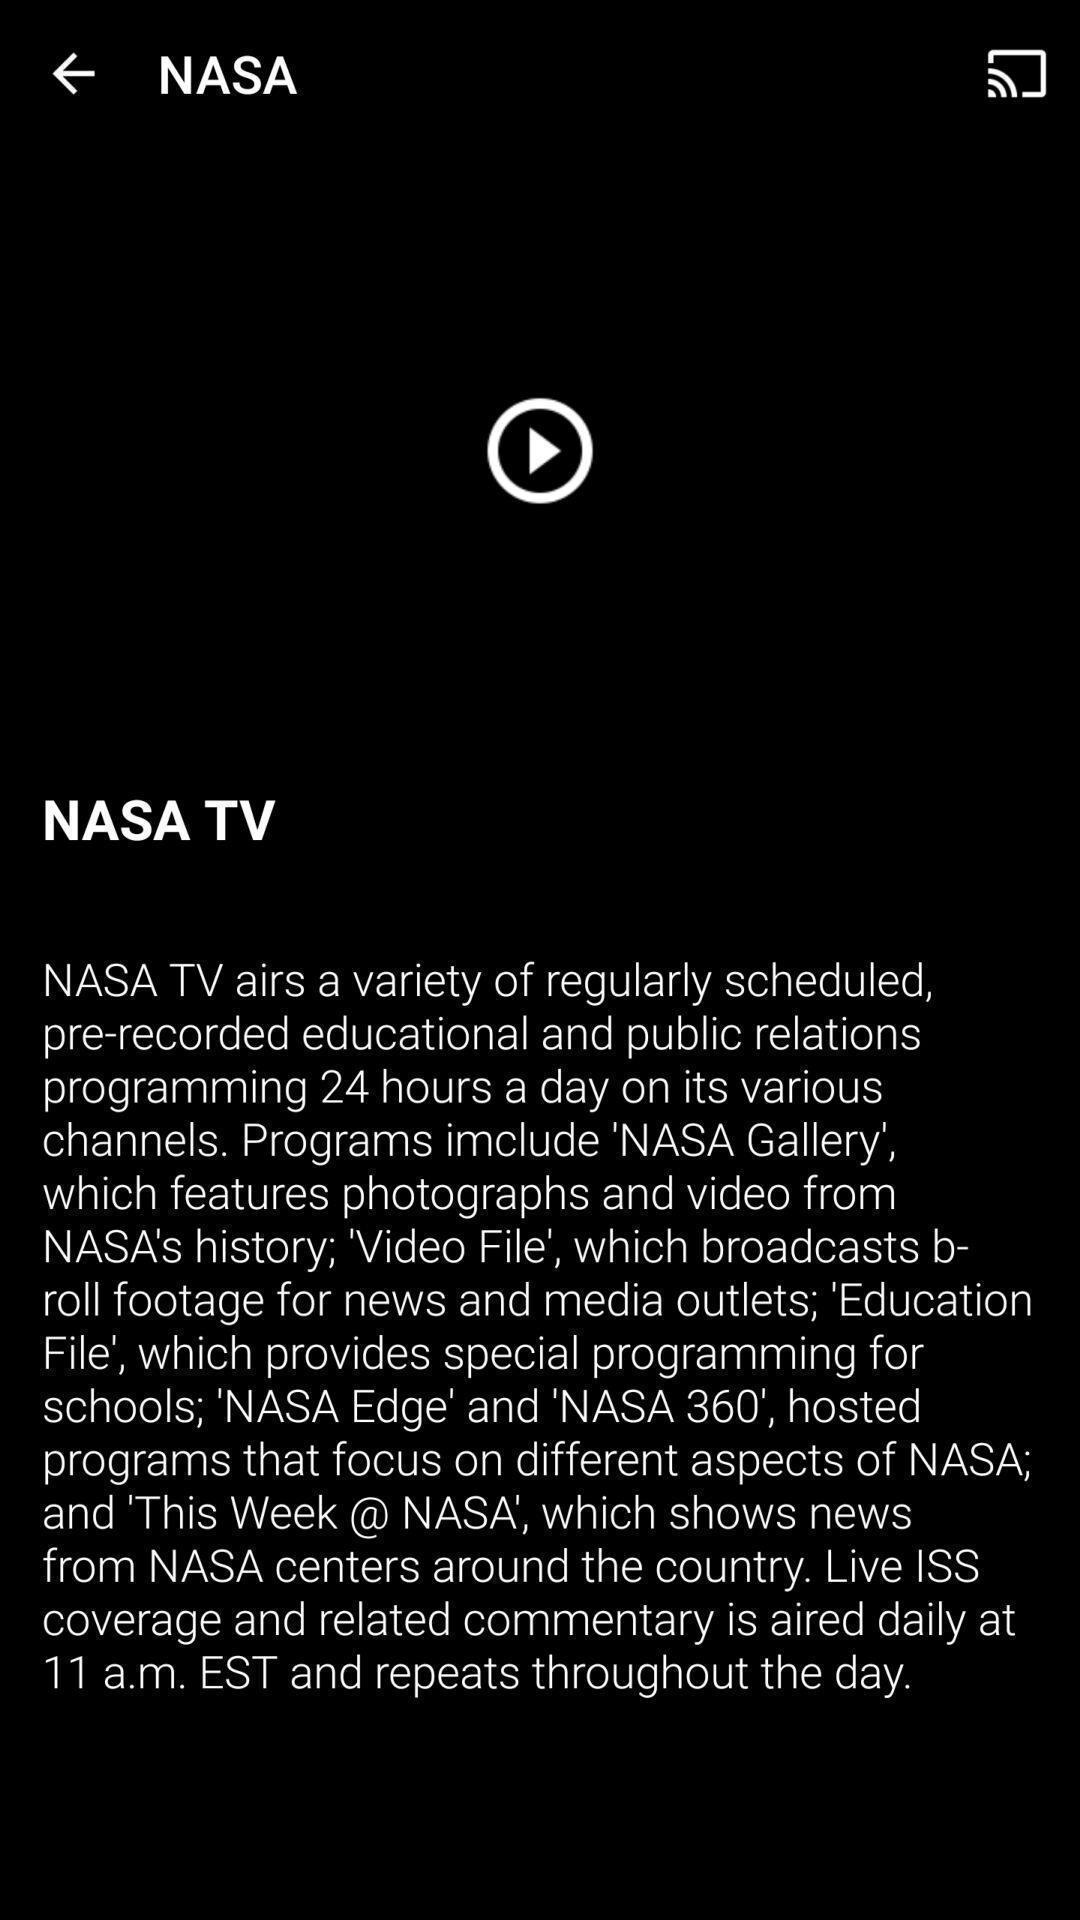Explain what's happening in this screen capture. Page showing the video thumbnail. 